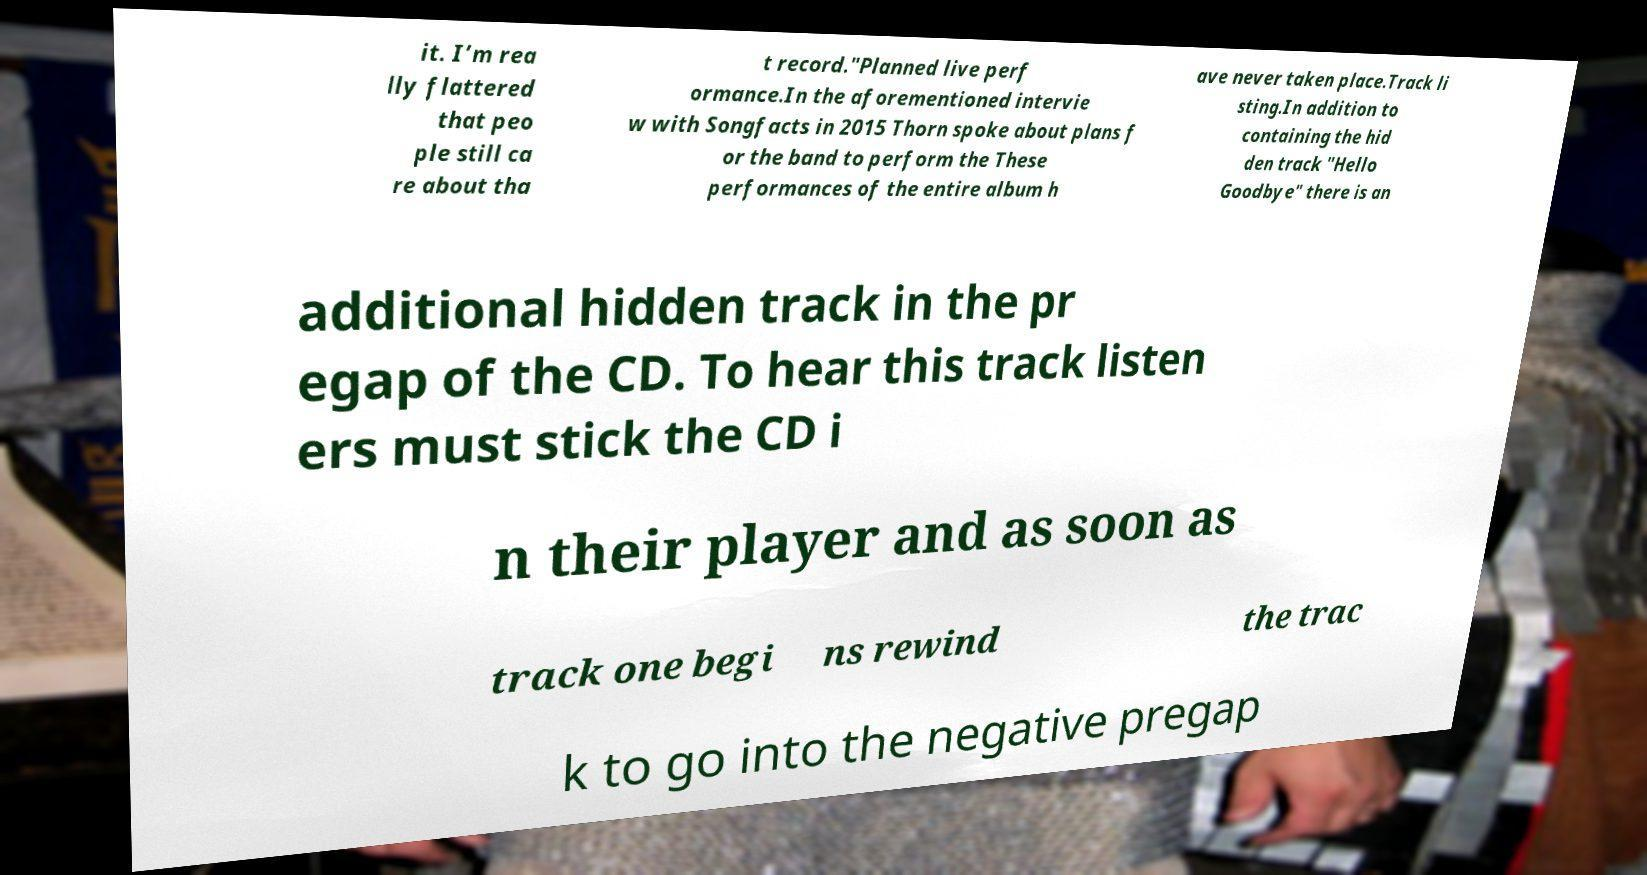What messages or text are displayed in this image? I need them in a readable, typed format. it. I’m rea lly flattered that peo ple still ca re about tha t record."Planned live perf ormance.In the aforementioned intervie w with Songfacts in 2015 Thorn spoke about plans f or the band to perform the These performances of the entire album h ave never taken place.Track li sting.In addition to containing the hid den track "Hello Goodbye" there is an additional hidden track in the pr egap of the CD. To hear this track listen ers must stick the CD i n their player and as soon as track one begi ns rewind the trac k to go into the negative pregap 